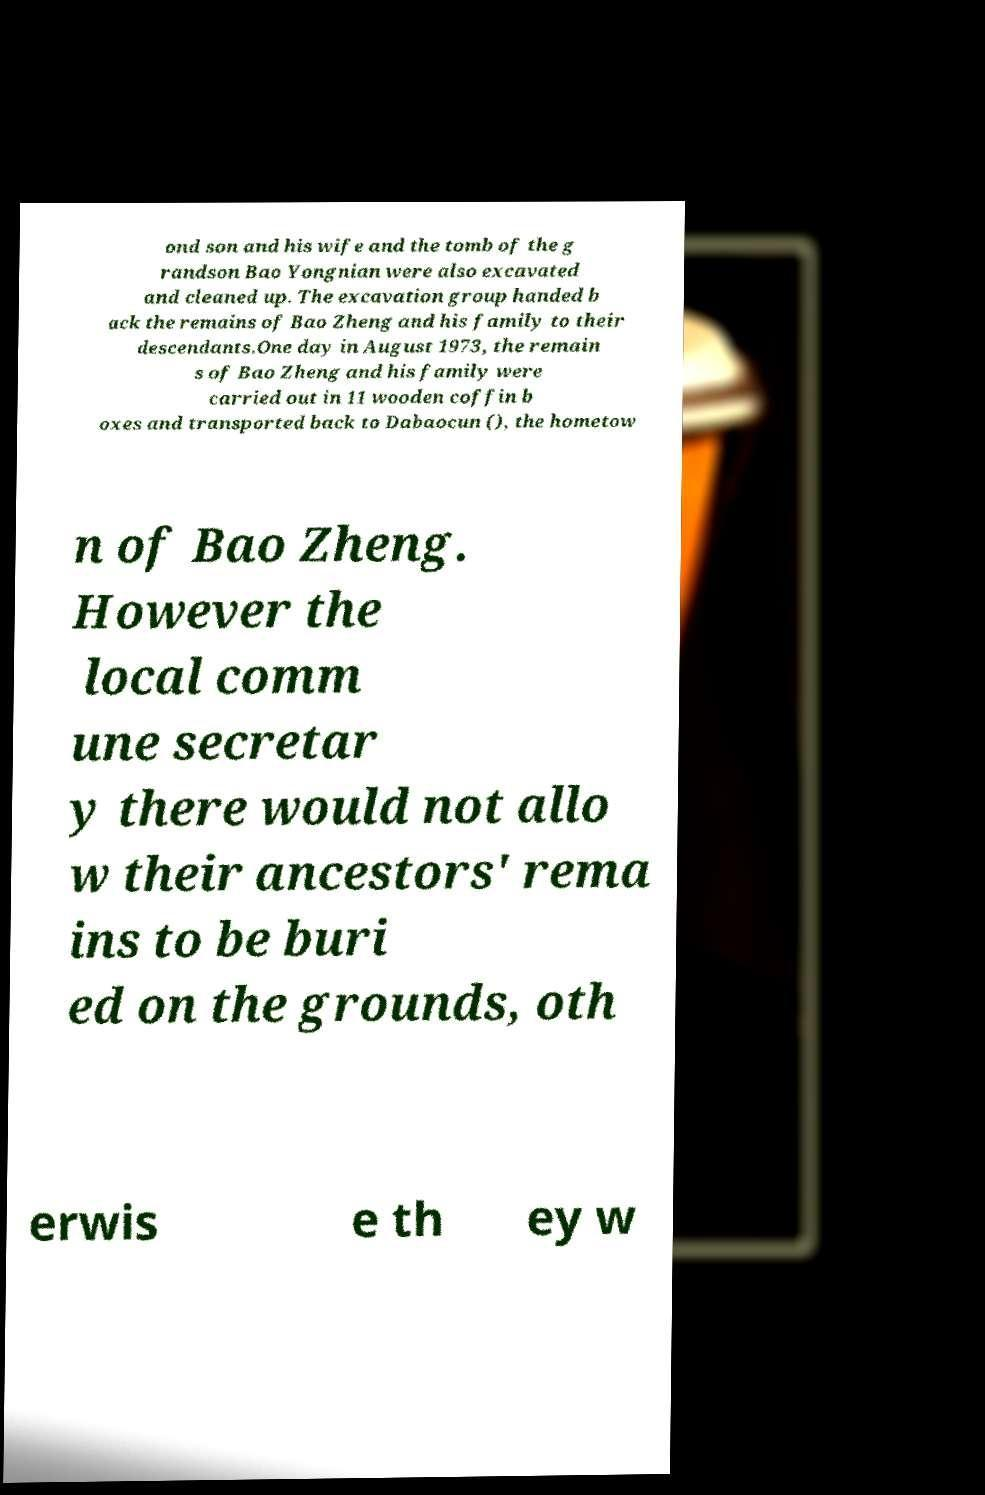Can you accurately transcribe the text from the provided image for me? ond son and his wife and the tomb of the g randson Bao Yongnian were also excavated and cleaned up. The excavation group handed b ack the remains of Bao Zheng and his family to their descendants.One day in August 1973, the remain s of Bao Zheng and his family were carried out in 11 wooden coffin b oxes and transported back to Dabaocun (), the hometow n of Bao Zheng. However the local comm une secretar y there would not allo w their ancestors' rema ins to be buri ed on the grounds, oth erwis e th ey w 